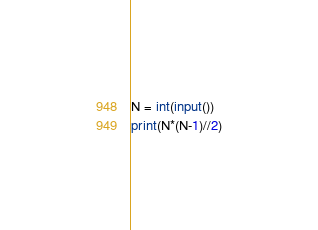Convert code to text. <code><loc_0><loc_0><loc_500><loc_500><_Python_>N = int(input())
print(N*(N-1)//2)
</code> 